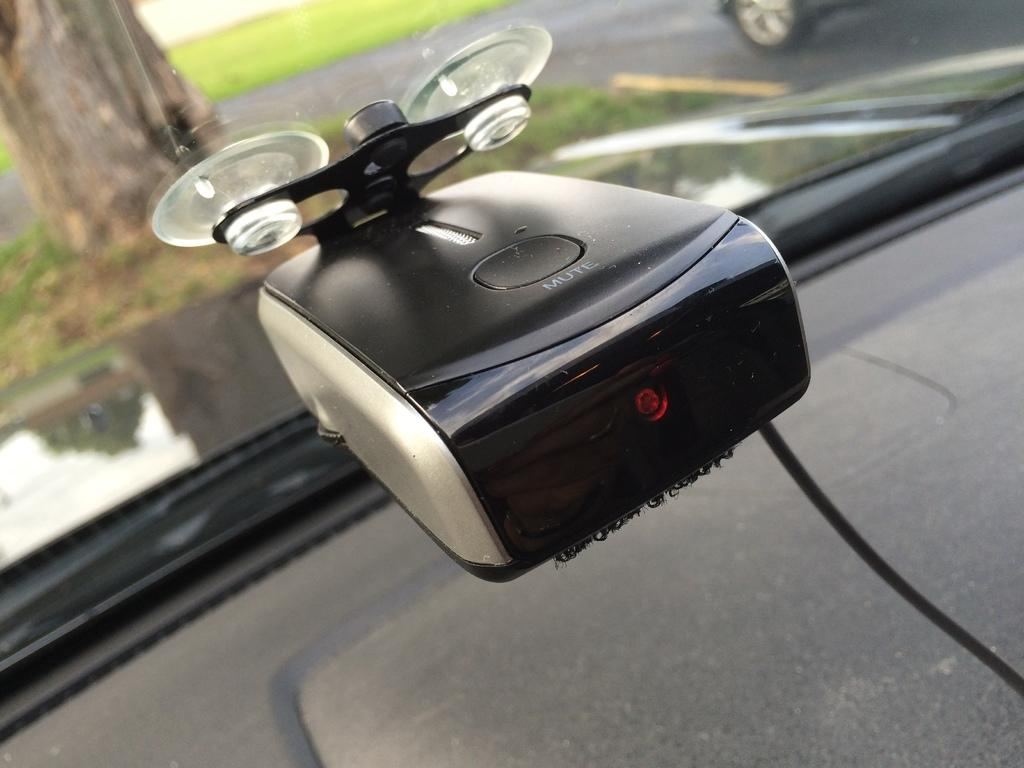What is the main object in the center of the image? There is a device-like object in the center of the image. What type of vehicle is at the bottom of the image? There is a vehicle at the bottom of the image. Can you describe the background of the image? The background of the image includes other vehicles, grass, and trees. What month is the company saying good-bye to in the image? There is no mention of a company or a specific month in the image. 